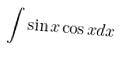Convert formula to latex. <formula><loc_0><loc_0><loc_500><loc_500>\int \sin x \cos x d x</formula> 